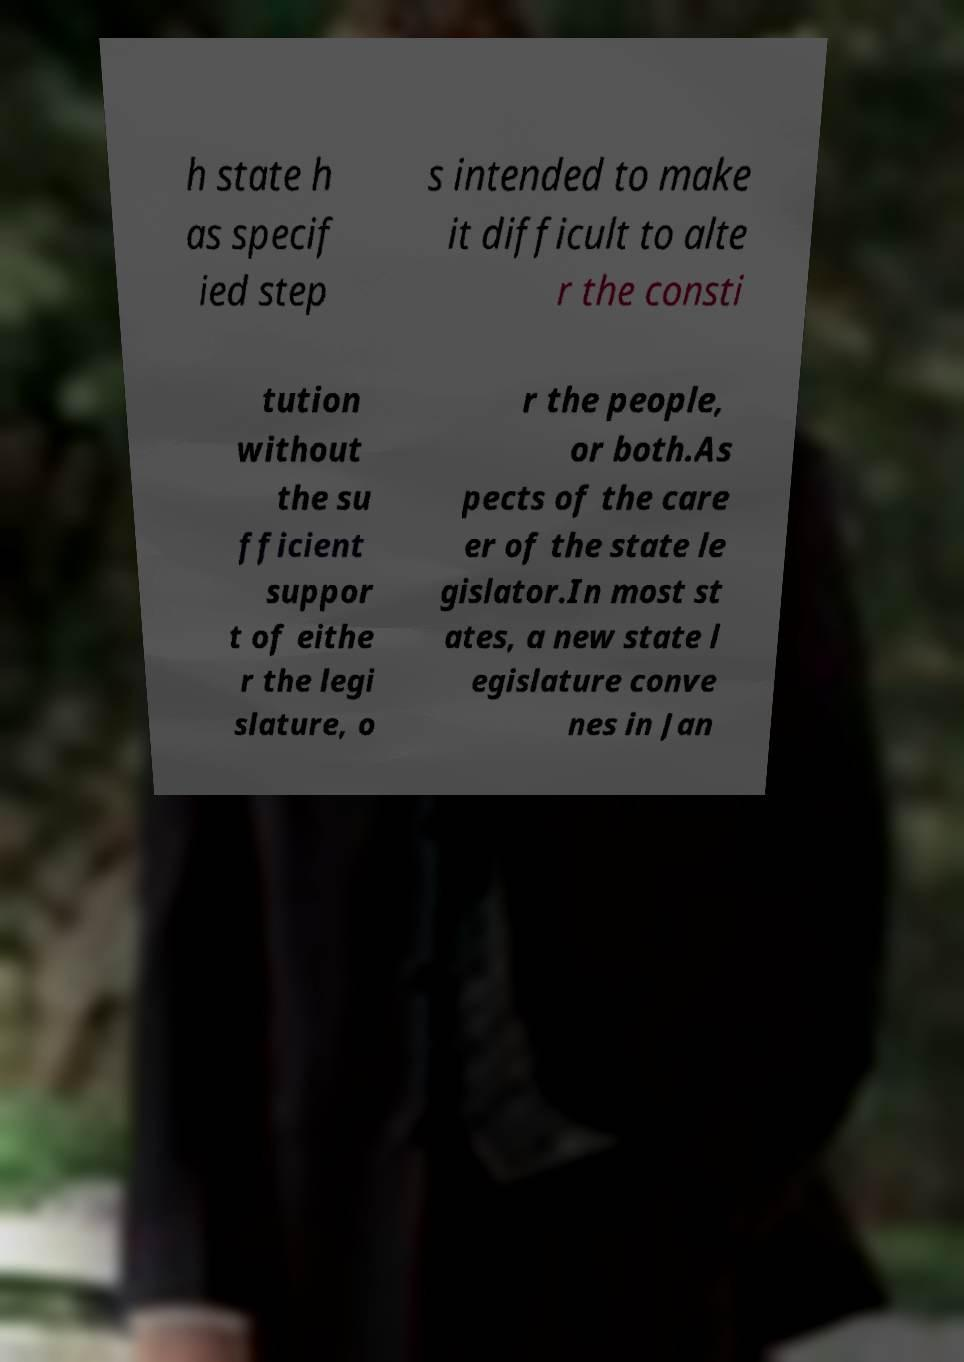There's text embedded in this image that I need extracted. Can you transcribe it verbatim? h state h as specif ied step s intended to make it difficult to alte r the consti tution without the su fficient suppor t of eithe r the legi slature, o r the people, or both.As pects of the care er of the state le gislator.In most st ates, a new state l egislature conve nes in Jan 